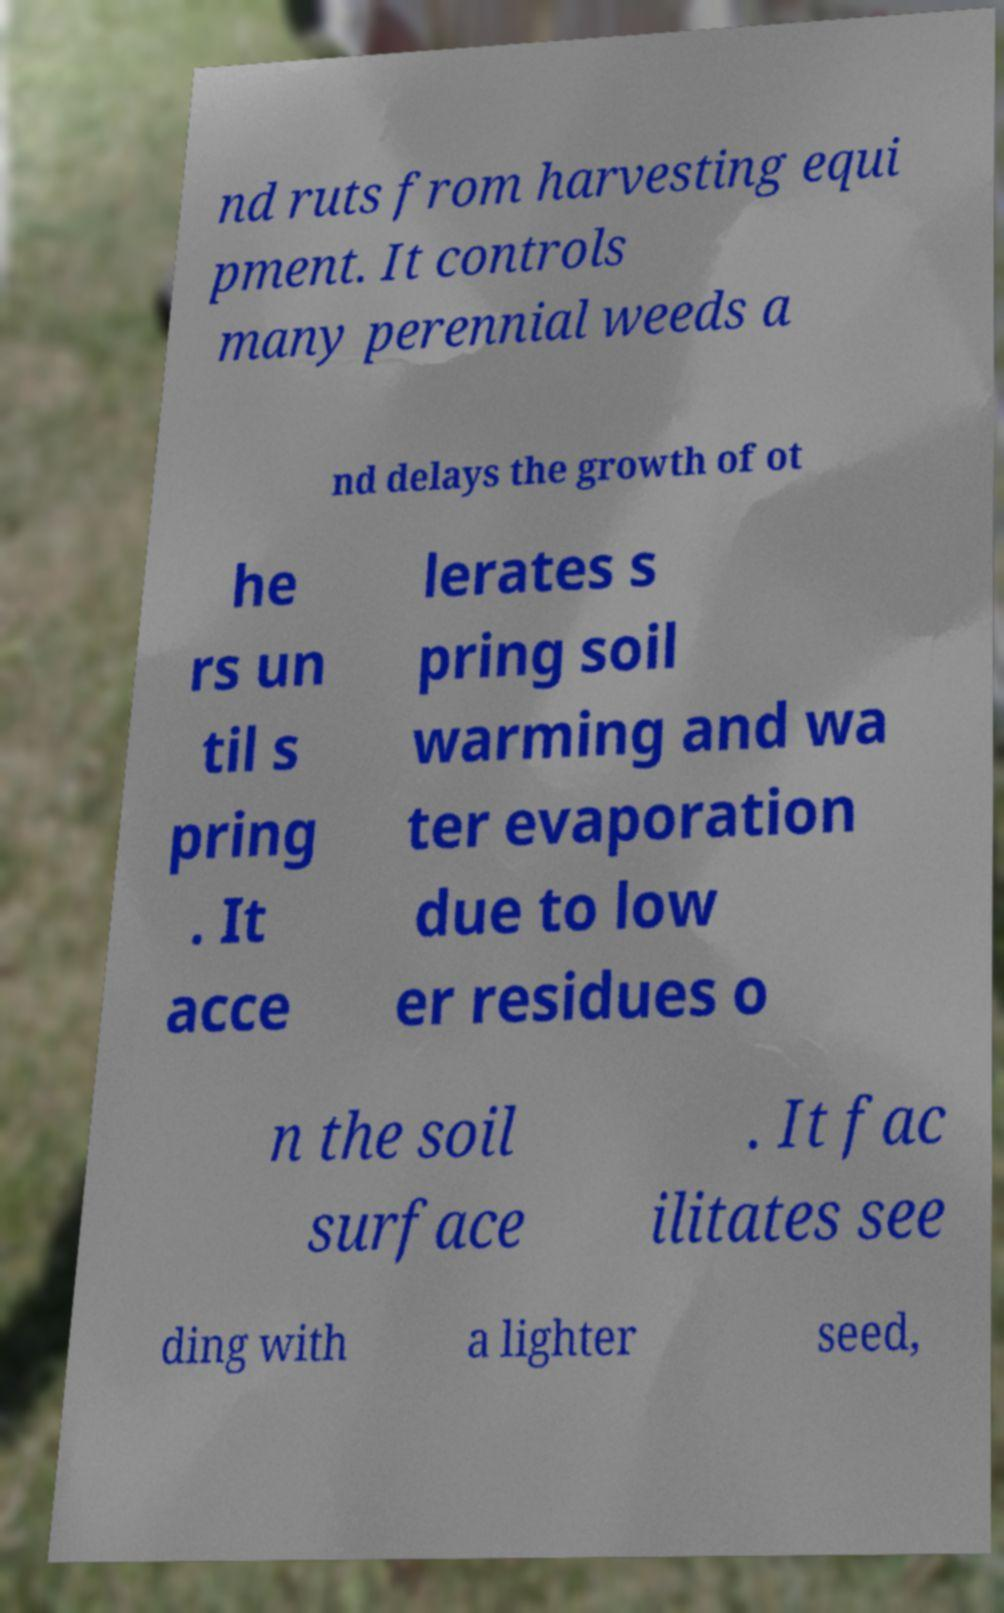Can you accurately transcribe the text from the provided image for me? nd ruts from harvesting equi pment. It controls many perennial weeds a nd delays the growth of ot he rs un til s pring . It acce lerates s pring soil warming and wa ter evaporation due to low er residues o n the soil surface . It fac ilitates see ding with a lighter seed, 